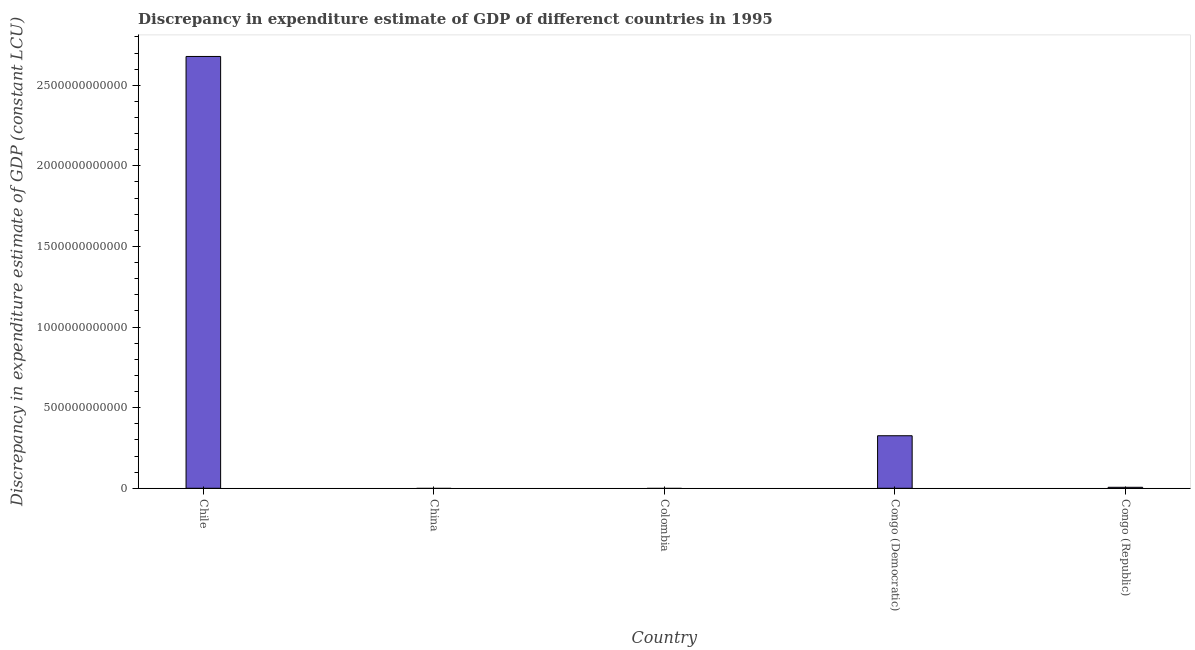Does the graph contain any zero values?
Offer a very short reply. Yes. What is the title of the graph?
Provide a succinct answer. Discrepancy in expenditure estimate of GDP of differenct countries in 1995. What is the label or title of the Y-axis?
Offer a terse response. Discrepancy in expenditure estimate of GDP (constant LCU). What is the discrepancy in expenditure estimate of gdp in Congo (Republic)?
Provide a succinct answer. 6.14e+09. Across all countries, what is the maximum discrepancy in expenditure estimate of gdp?
Offer a very short reply. 2.68e+12. Across all countries, what is the minimum discrepancy in expenditure estimate of gdp?
Offer a terse response. 0. What is the sum of the discrepancy in expenditure estimate of gdp?
Make the answer very short. 3.01e+12. What is the difference between the discrepancy in expenditure estimate of gdp in Chile and Congo (Democratic)?
Offer a very short reply. 2.35e+12. What is the average discrepancy in expenditure estimate of gdp per country?
Your response must be concise. 6.02e+11. What is the median discrepancy in expenditure estimate of gdp?
Your answer should be very brief. 6.14e+09. What is the ratio of the discrepancy in expenditure estimate of gdp in Chile to that in Congo (Democratic)?
Offer a very short reply. 8.22. Is the discrepancy in expenditure estimate of gdp in Congo (Democratic) less than that in Congo (Republic)?
Ensure brevity in your answer.  No. Is the difference between the discrepancy in expenditure estimate of gdp in Chile and Congo (Democratic) greater than the difference between any two countries?
Your response must be concise. No. What is the difference between the highest and the second highest discrepancy in expenditure estimate of gdp?
Ensure brevity in your answer.  2.35e+12. What is the difference between the highest and the lowest discrepancy in expenditure estimate of gdp?
Offer a terse response. 2.68e+12. Are all the bars in the graph horizontal?
Offer a very short reply. No. How many countries are there in the graph?
Provide a short and direct response. 5. What is the difference between two consecutive major ticks on the Y-axis?
Give a very brief answer. 5.00e+11. What is the Discrepancy in expenditure estimate of GDP (constant LCU) in Chile?
Keep it short and to the point. 2.68e+12. What is the Discrepancy in expenditure estimate of GDP (constant LCU) of Colombia?
Provide a succinct answer. 0. What is the Discrepancy in expenditure estimate of GDP (constant LCU) of Congo (Democratic)?
Offer a very short reply. 3.26e+11. What is the Discrepancy in expenditure estimate of GDP (constant LCU) of Congo (Republic)?
Make the answer very short. 6.14e+09. What is the difference between the Discrepancy in expenditure estimate of GDP (constant LCU) in Chile and Congo (Democratic)?
Make the answer very short. 2.35e+12. What is the difference between the Discrepancy in expenditure estimate of GDP (constant LCU) in Chile and Congo (Republic)?
Offer a terse response. 2.67e+12. What is the difference between the Discrepancy in expenditure estimate of GDP (constant LCU) in Congo (Democratic) and Congo (Republic)?
Offer a very short reply. 3.20e+11. What is the ratio of the Discrepancy in expenditure estimate of GDP (constant LCU) in Chile to that in Congo (Democratic)?
Provide a succinct answer. 8.22. What is the ratio of the Discrepancy in expenditure estimate of GDP (constant LCU) in Chile to that in Congo (Republic)?
Offer a terse response. 436.25. What is the ratio of the Discrepancy in expenditure estimate of GDP (constant LCU) in Congo (Democratic) to that in Congo (Republic)?
Ensure brevity in your answer.  53.08. 